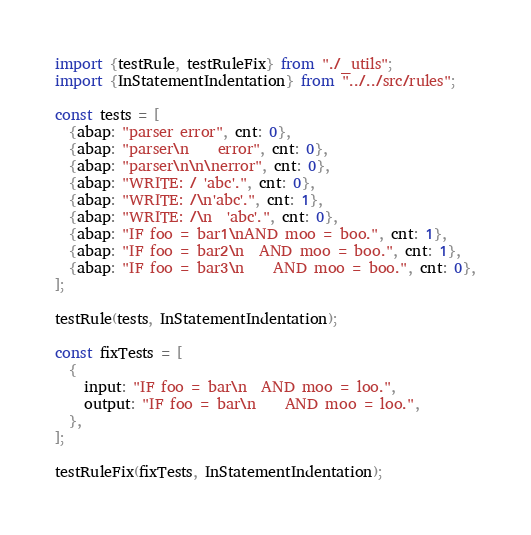<code> <loc_0><loc_0><loc_500><loc_500><_TypeScript_>import {testRule, testRuleFix} from "./_utils";
import {InStatementIndentation} from "../../src/rules";

const tests = [
  {abap: "parser error", cnt: 0},
  {abap: "parser\n    error", cnt: 0},
  {abap: "parser\n\n\nerror", cnt: 0},
  {abap: "WRITE: / 'abc'.", cnt: 0},
  {abap: "WRITE: /\n'abc'.", cnt: 1},
  {abap: "WRITE: /\n  'abc'.", cnt: 0},
  {abap: "IF foo = bar1\nAND moo = boo.", cnt: 1},
  {abap: "IF foo = bar2\n  AND moo = boo.", cnt: 1},
  {abap: "IF foo = bar3\n    AND moo = boo.", cnt: 0},
];

testRule(tests, InStatementIndentation);

const fixTests = [
  {
    input: "IF foo = bar\n  AND moo = loo.",
    output: "IF foo = bar\n    AND moo = loo.",
  },
];

testRuleFix(fixTests, InStatementIndentation);</code> 